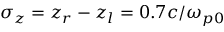<formula> <loc_0><loc_0><loc_500><loc_500>\sigma _ { z } = z _ { r } - z _ { l } = 0 . 7 { c } / { \omega _ { p 0 } }</formula> 